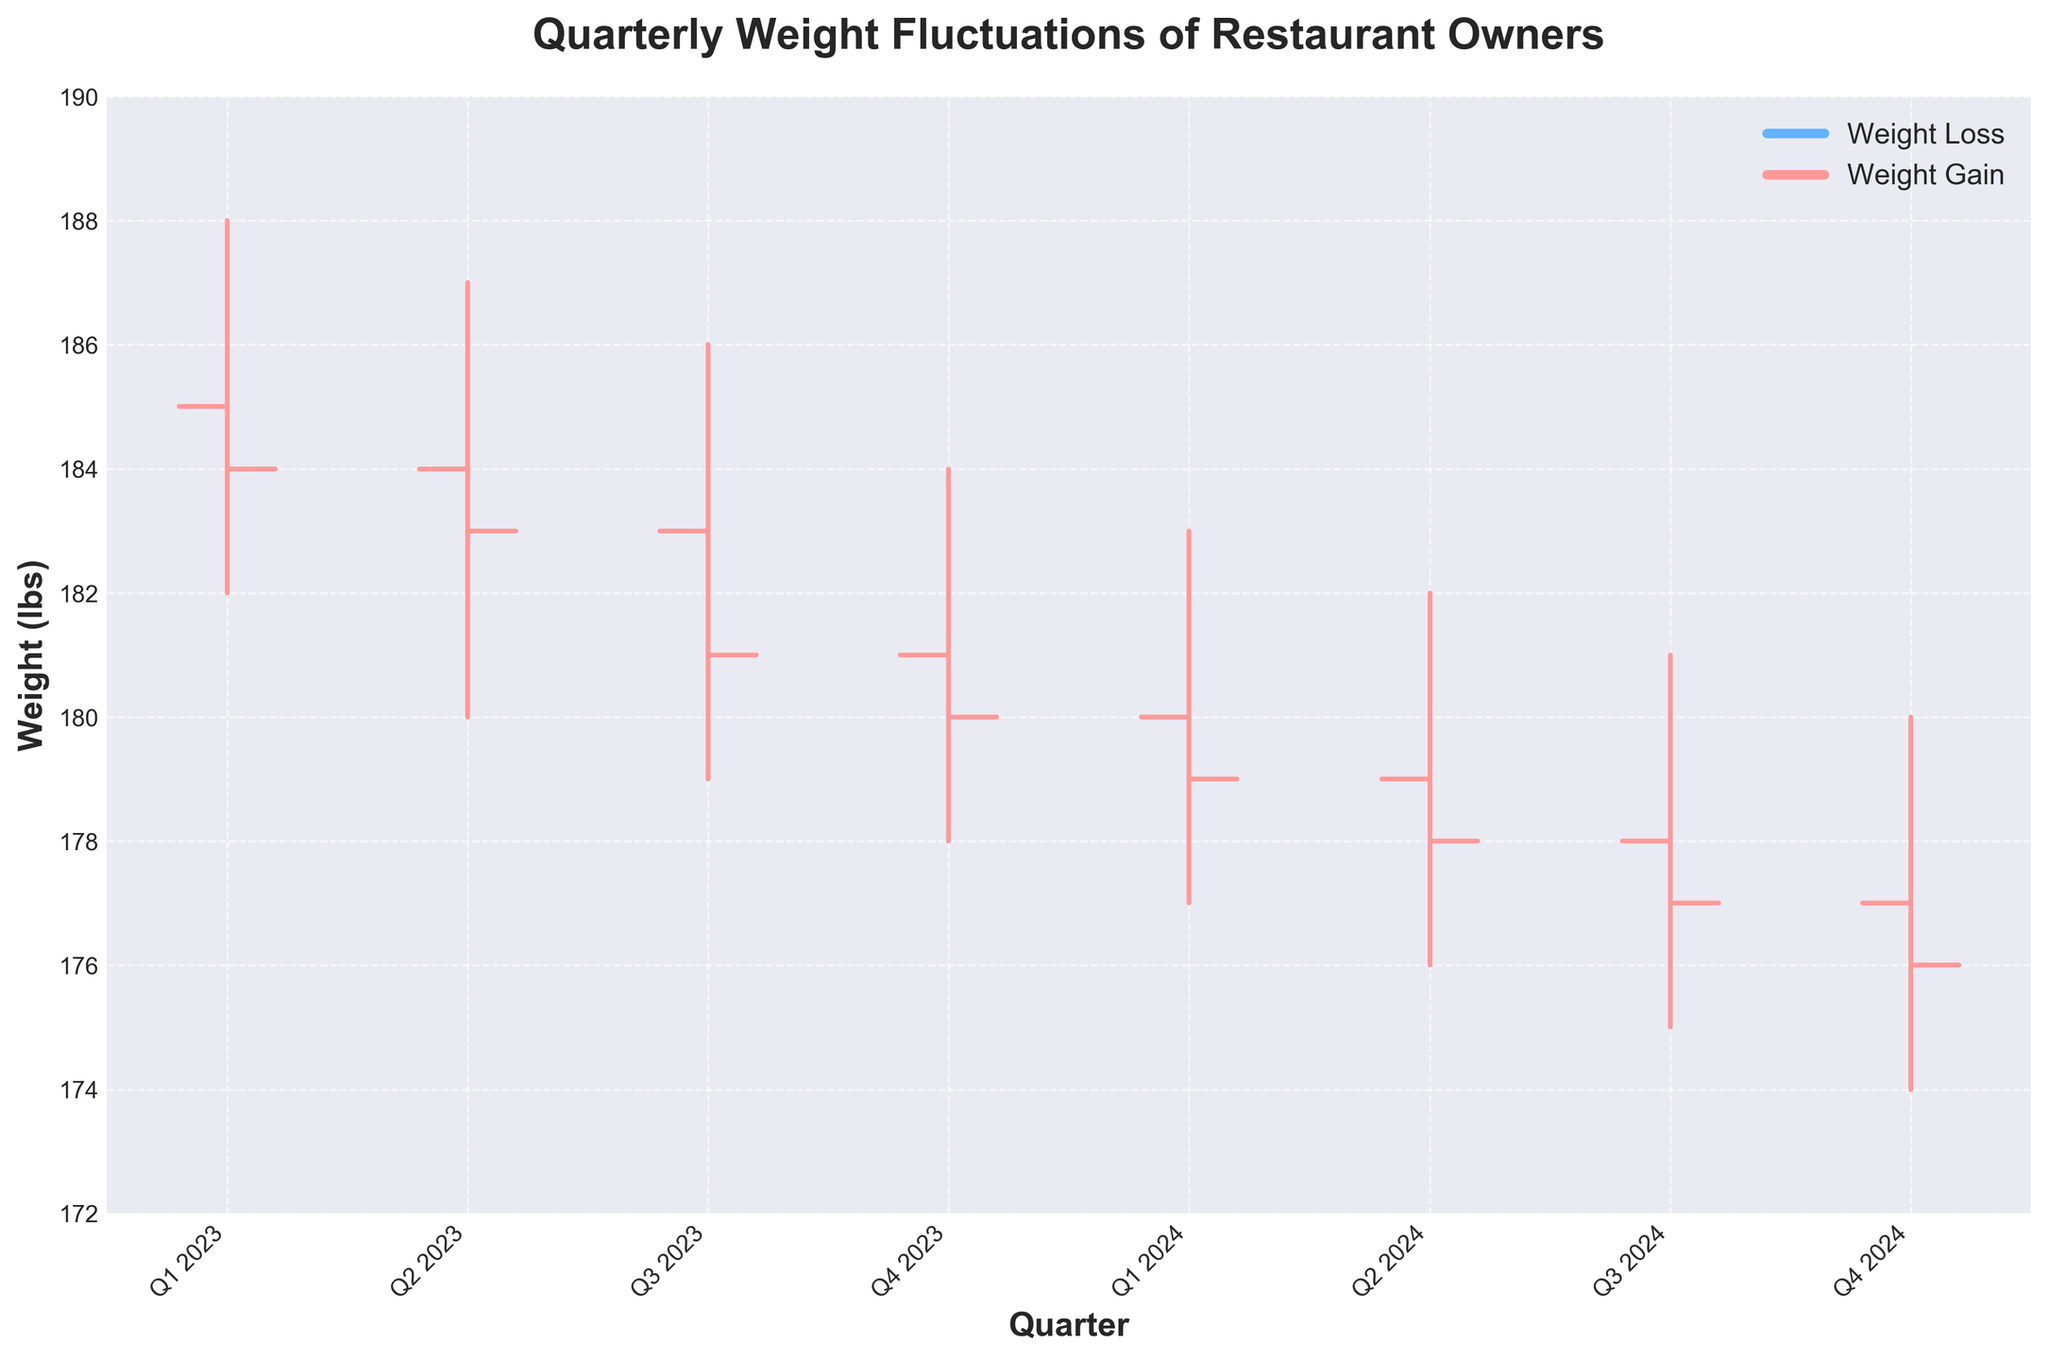What is the title of the chart? The title is displayed at the top of the figure and reads "Quarterly Weight Fluctuations of Restaurant Owners."
Answer: Quarterly Weight Fluctuations of Restaurant Owners What is the weight trend from Q1 2023 to Q4 2024? The weights are decreasing each quarter as seen in the 'Close' values. From Q1 2023 (184 lbs) to Q4 2024 (176 lbs), there is a clear downward trend.
Answer: Decreasing Which quarter had the highest peak weight? The highest peak weight is indicated by the 'High' value in the chart. The highest value is 188 lbs in Q1 2023.
Answer: Q1 2023 Did any quarter experience weight gain overall? Weight gain occurs when the 'Close' value is higher than the 'Open' value for a quarter. Observing the chart, no quarter shows a 'Close' value higher than the 'Open' value for that quarter.
Answer: No What was the weight loss from the highest peak to the lowest point throughout the period? The highest peak weight is 188 lbs in Q1 2023 and the lowest point is 174 lbs in Q4 2024. The weight loss is calculated as 188 lbs - 174 lbs = 14 lbs.
Answer: 14 lbs What was the average starting weight in 2023? The starting weights (Open values) in 2023 are 185 lbs, 184 lbs, 183 lbs, and 181 lbs. The average is (185 + 184 + 183 + 181) / 4 = 183.25 lbs.
Answer: 183.25 lbs Compare the weight range (High - Low) for Q1 2023 and Q4 2023. Which quarter had a larger fluctuation? For Q1 2023, the range is 188 - 182 = 6 lbs. For Q4 2023, the range is 184 - 178 = 6 lbs. Both quarters had the same fluctuation.
Answer: Same Which quarter shows the greatest single weight drop from open to close? To find the greatest drop, subtract the 'Close' from the 'Open' for each quarter and find the maximum. The greatest drop is from Q3 2023, with 183 - 181 = 2 lbs.
Answer: Q3 2023 